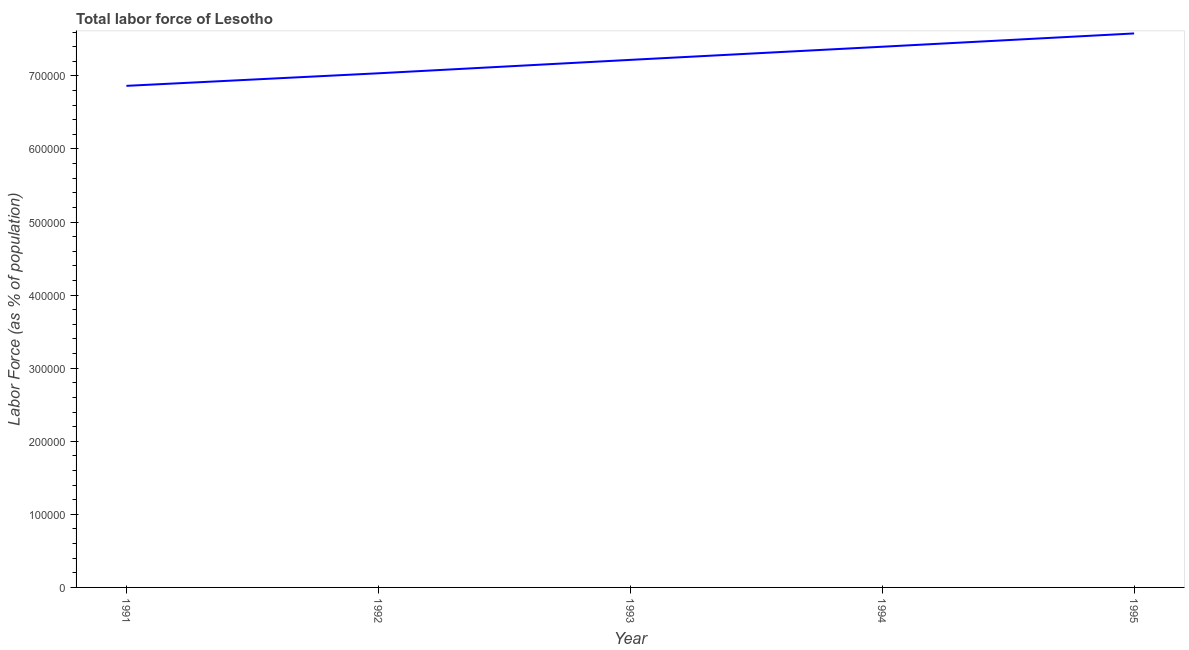What is the total labor force in 1993?
Offer a very short reply. 7.22e+05. Across all years, what is the maximum total labor force?
Provide a short and direct response. 7.58e+05. Across all years, what is the minimum total labor force?
Ensure brevity in your answer.  6.86e+05. In which year was the total labor force minimum?
Offer a very short reply. 1991. What is the sum of the total labor force?
Offer a terse response. 3.61e+06. What is the difference between the total labor force in 1991 and 1993?
Make the answer very short. -3.55e+04. What is the average total labor force per year?
Offer a terse response. 7.22e+05. What is the median total labor force?
Provide a short and direct response. 7.22e+05. In how many years, is the total labor force greater than 240000 %?
Provide a succinct answer. 5. What is the ratio of the total labor force in 1991 to that in 1993?
Provide a succinct answer. 0.95. Is the difference between the total labor force in 1991 and 1995 greater than the difference between any two years?
Your answer should be very brief. Yes. What is the difference between the highest and the second highest total labor force?
Offer a very short reply. 1.82e+04. What is the difference between the highest and the lowest total labor force?
Your answer should be very brief. 7.17e+04. Does the total labor force monotonically increase over the years?
Your response must be concise. Yes. What is the difference between two consecutive major ticks on the Y-axis?
Keep it short and to the point. 1.00e+05. Does the graph contain grids?
Your answer should be compact. No. What is the title of the graph?
Offer a terse response. Total labor force of Lesotho. What is the label or title of the Y-axis?
Offer a very short reply. Labor Force (as % of population). What is the Labor Force (as % of population) in 1991?
Ensure brevity in your answer.  6.86e+05. What is the Labor Force (as % of population) of 1992?
Ensure brevity in your answer.  7.04e+05. What is the Labor Force (as % of population) in 1993?
Offer a very short reply. 7.22e+05. What is the Labor Force (as % of population) of 1994?
Provide a short and direct response. 7.40e+05. What is the Labor Force (as % of population) of 1995?
Give a very brief answer. 7.58e+05. What is the difference between the Labor Force (as % of population) in 1991 and 1992?
Your answer should be compact. -1.72e+04. What is the difference between the Labor Force (as % of population) in 1991 and 1993?
Offer a terse response. -3.55e+04. What is the difference between the Labor Force (as % of population) in 1991 and 1994?
Give a very brief answer. -5.35e+04. What is the difference between the Labor Force (as % of population) in 1991 and 1995?
Your response must be concise. -7.17e+04. What is the difference between the Labor Force (as % of population) in 1992 and 1993?
Provide a short and direct response. -1.83e+04. What is the difference between the Labor Force (as % of population) in 1992 and 1994?
Give a very brief answer. -3.63e+04. What is the difference between the Labor Force (as % of population) in 1992 and 1995?
Offer a terse response. -5.45e+04. What is the difference between the Labor Force (as % of population) in 1993 and 1994?
Provide a short and direct response. -1.80e+04. What is the difference between the Labor Force (as % of population) in 1993 and 1995?
Offer a very short reply. -3.62e+04. What is the difference between the Labor Force (as % of population) in 1994 and 1995?
Your response must be concise. -1.82e+04. What is the ratio of the Labor Force (as % of population) in 1991 to that in 1992?
Provide a succinct answer. 0.98. What is the ratio of the Labor Force (as % of population) in 1991 to that in 1993?
Your answer should be compact. 0.95. What is the ratio of the Labor Force (as % of population) in 1991 to that in 1994?
Your answer should be compact. 0.93. What is the ratio of the Labor Force (as % of population) in 1991 to that in 1995?
Offer a very short reply. 0.91. What is the ratio of the Labor Force (as % of population) in 1992 to that in 1994?
Give a very brief answer. 0.95. What is the ratio of the Labor Force (as % of population) in 1992 to that in 1995?
Offer a very short reply. 0.93. What is the ratio of the Labor Force (as % of population) in 1994 to that in 1995?
Ensure brevity in your answer.  0.98. 